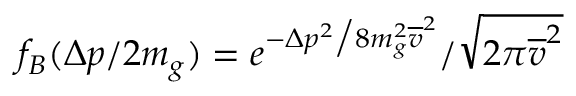<formula> <loc_0><loc_0><loc_500><loc_500>f _ { B } ( \Delta p / 2 m _ { g } ) = e ^ { - \Delta p ^ { 2 } \Big / 8 m _ { g } ^ { 2 } \overline { v } ^ { 2 } } / \sqrt { 2 \pi \overline { v } ^ { 2 } }</formula> 